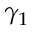Convert formula to latex. <formula><loc_0><loc_0><loc_500><loc_500>\gamma _ { 1 }</formula> 